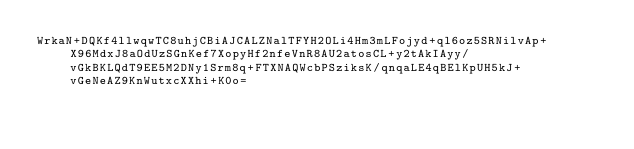<code> <loc_0><loc_0><loc_500><loc_500><_SML_>WrkaN+DQKf4llwqwTC8uhjCBiAJCALZNalTFYH2OLi4Hm3mLFojyd+ql6oz5SRNilvAp+X96MdxJ8aOdUzSGnKef7XopyHf2nfeVnR8AU2atosCL+y2tAkIAyy/vGkBKLQdT9EE5M2DNy1Srm8q+FTXNAQWcbPSziksK/qnqaLE4qBElKpUH5kJ+vGeNeAZ9KnWutxcXXhi+K0o=</code> 